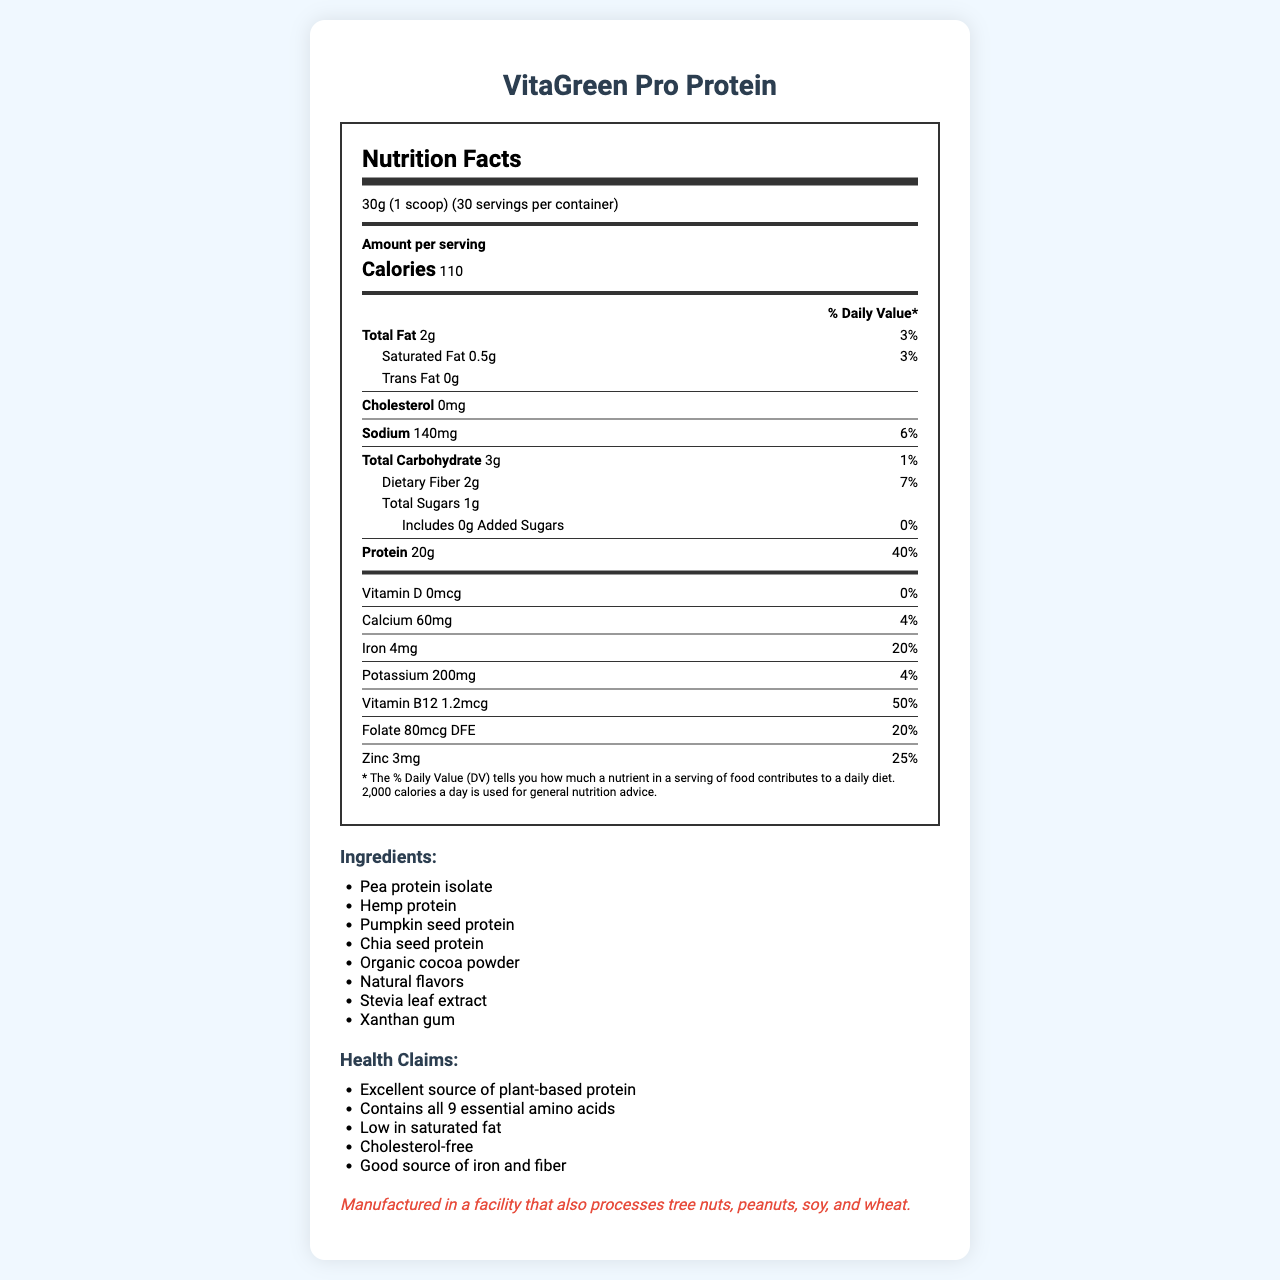what is the serving size for VitaGreen Pro Protein? The document states that the serving size for VitaGreen Pro Protein is 30g, which is equivalent to 1 scoop.
Answer: 30g (1 scoop) how many servings are there per container? The document indicates that there are 30 servings per container.
Answer: 30 how many grams of total fat are there per serving? Under the "Total Fat" section, it's mentioned that there are 2 grams of total fat per serving.
Answer: 2g what percentage of the daily value is the protein content per serving? For protein, the document lists that it contributes 40% to the daily value.
Answer: 40% name two plant-based protein sources in the ingredient list. The ingredients list includes several plant-based protein sources, including pea protein isolate and hemp protein.
Answer: Pea protein isolate, Hemp protein which vitamin listed has the highest percentage of daily value?  A. Vitamin D B. Vitamin B12 C. Folate D. Zinc Vitamin B12 has the highest percentage of the daily value at 50%, as indicated in the document.
Answer: B. Vitamin B12 how much iron is in each serving?  A. 4mg B. 60mg C. 200mg D. 140mg The nutrition label states that each serving contains 4mg of iron.
Answer: A. 4mg how much sodium does VitaGreen Pro Protein contain per serving? According to the document, the sodium content per serving is 140mg.
Answer: 140mg is there any trans fat in VitaGreen Pro Protein? The document states that the trans fat content is 0g.
Answer: No what is the primary focus of this document? The document comprises a detailed nutrition label, ingredient list, and health claims related to VitaGreen Pro Protein, along with some research notes on its efficiency, digestibility, and sustainability indicators.
Answer: The primary focus is on presenting the nutrition facts, ingredient list, health claims, and additional product information for VitaGreen Pro Protein. how many grams of carbohydrates are there per serving? The document clearly mentions that there are 3 grams of total carbohydrates per serving.
Answer: 3g does the product contain any cholesterol? The document specifies that the cholesterol content is 0mg, indicating there is no cholesterol.
Answer: No does the product have any added sugars?  A. Yes B. No C. Cannot be determined The nutrition facts indicate that the amount of added sugars is 0g.
Answer: B. No how many grams of leucine are in each serving? The document does not specify the grams of leucine per serving; it only provides the total amount of each amino acid.
Answer: Cannot be determined what are some health claims made about the product? The health claims section lists these benefits explicitly.
Answer: Excellent source of plant-based protein, Contains all 9 essential amino acids, Low in saturated fat, Cholesterol-free, Good source of iron and fiber what type of facility is VitaGreen Pro Protein manufactured in? The allergen information states that the product is manufactured in a facility that processes these allergens.
Answer: A facility that also processes tree nuts, peanuts, soy, and wheat 